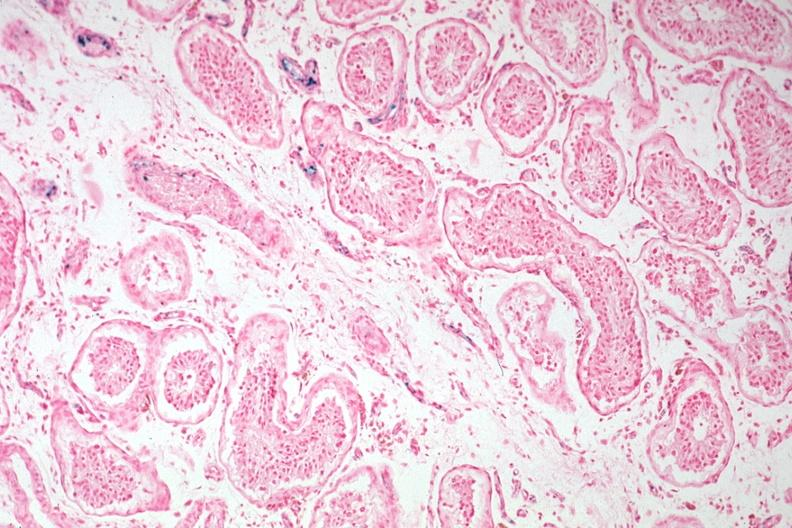does this image show iron stain tubular atrophy and interstitial iron deposits?
Answer the question using a single word or phrase. Yes 